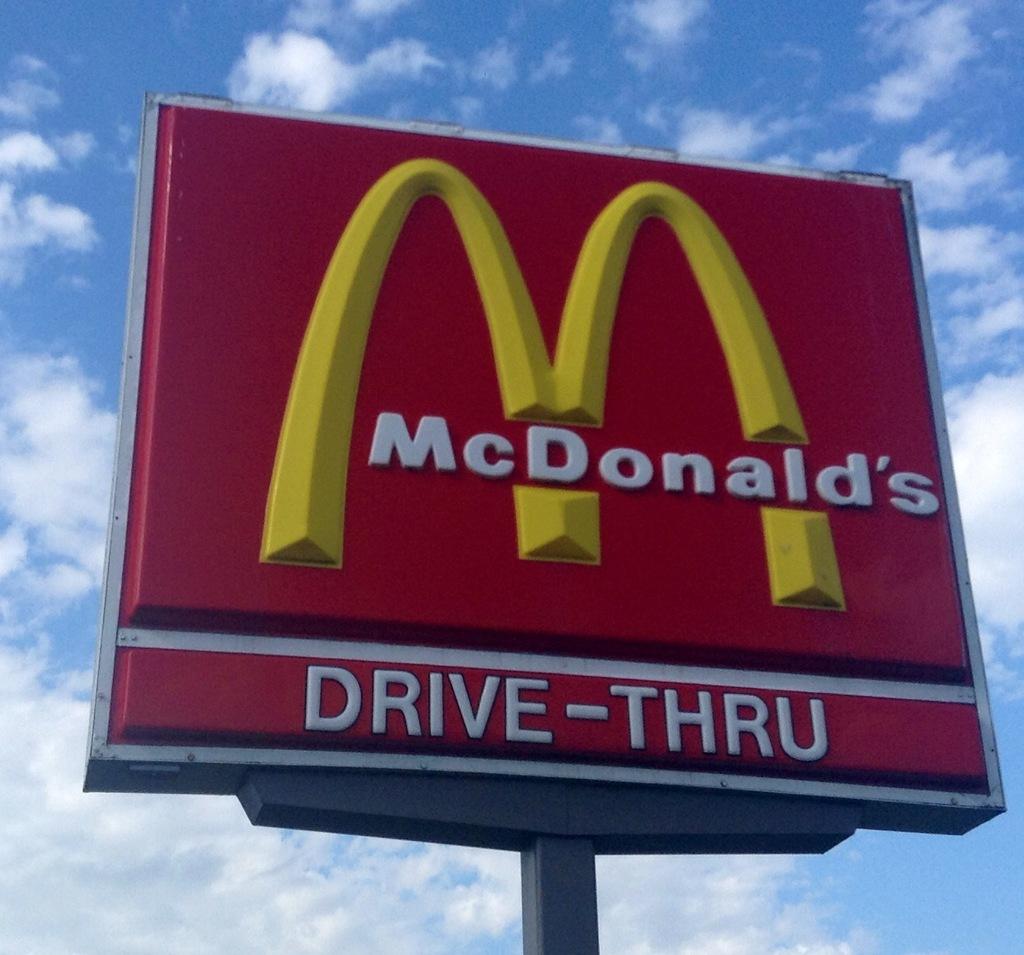Does this restaurant have a drive through?
Your response must be concise. Yes. Yes drive thru available?
Ensure brevity in your answer.  Yes. 